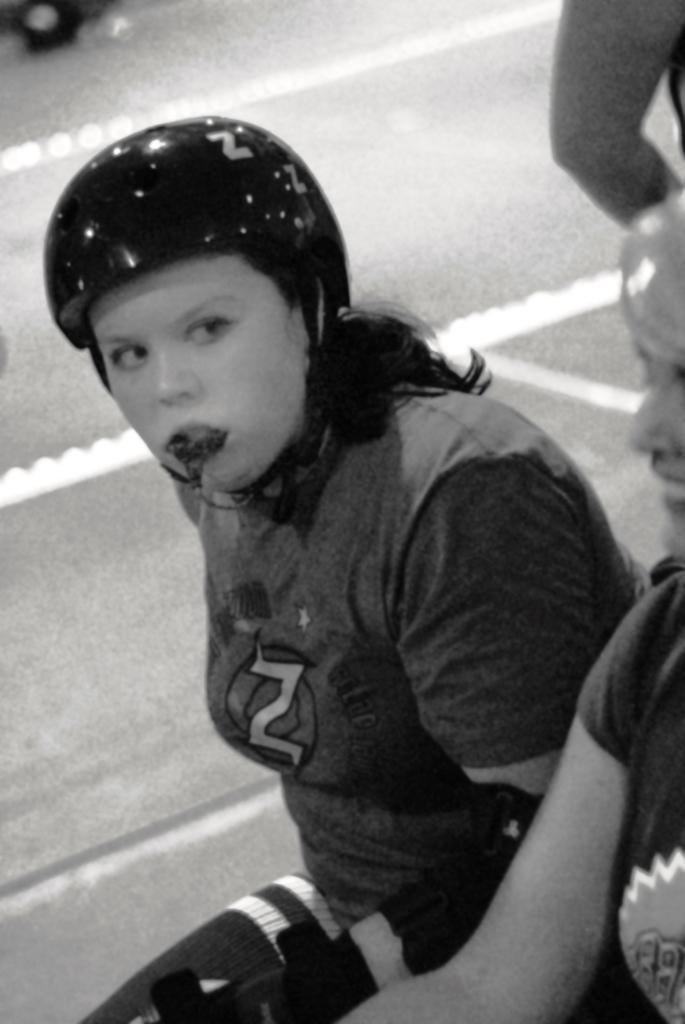Could you give a brief overview of what you see in this image? This is a zoomed in picture. On the right corner there is a person seems to be sitting. In the center there is a woman wearing a helmet, t-shirt, holding some object in her mouth and seems to be sitting. In the background we can see a person seems to be walking on the ground. 